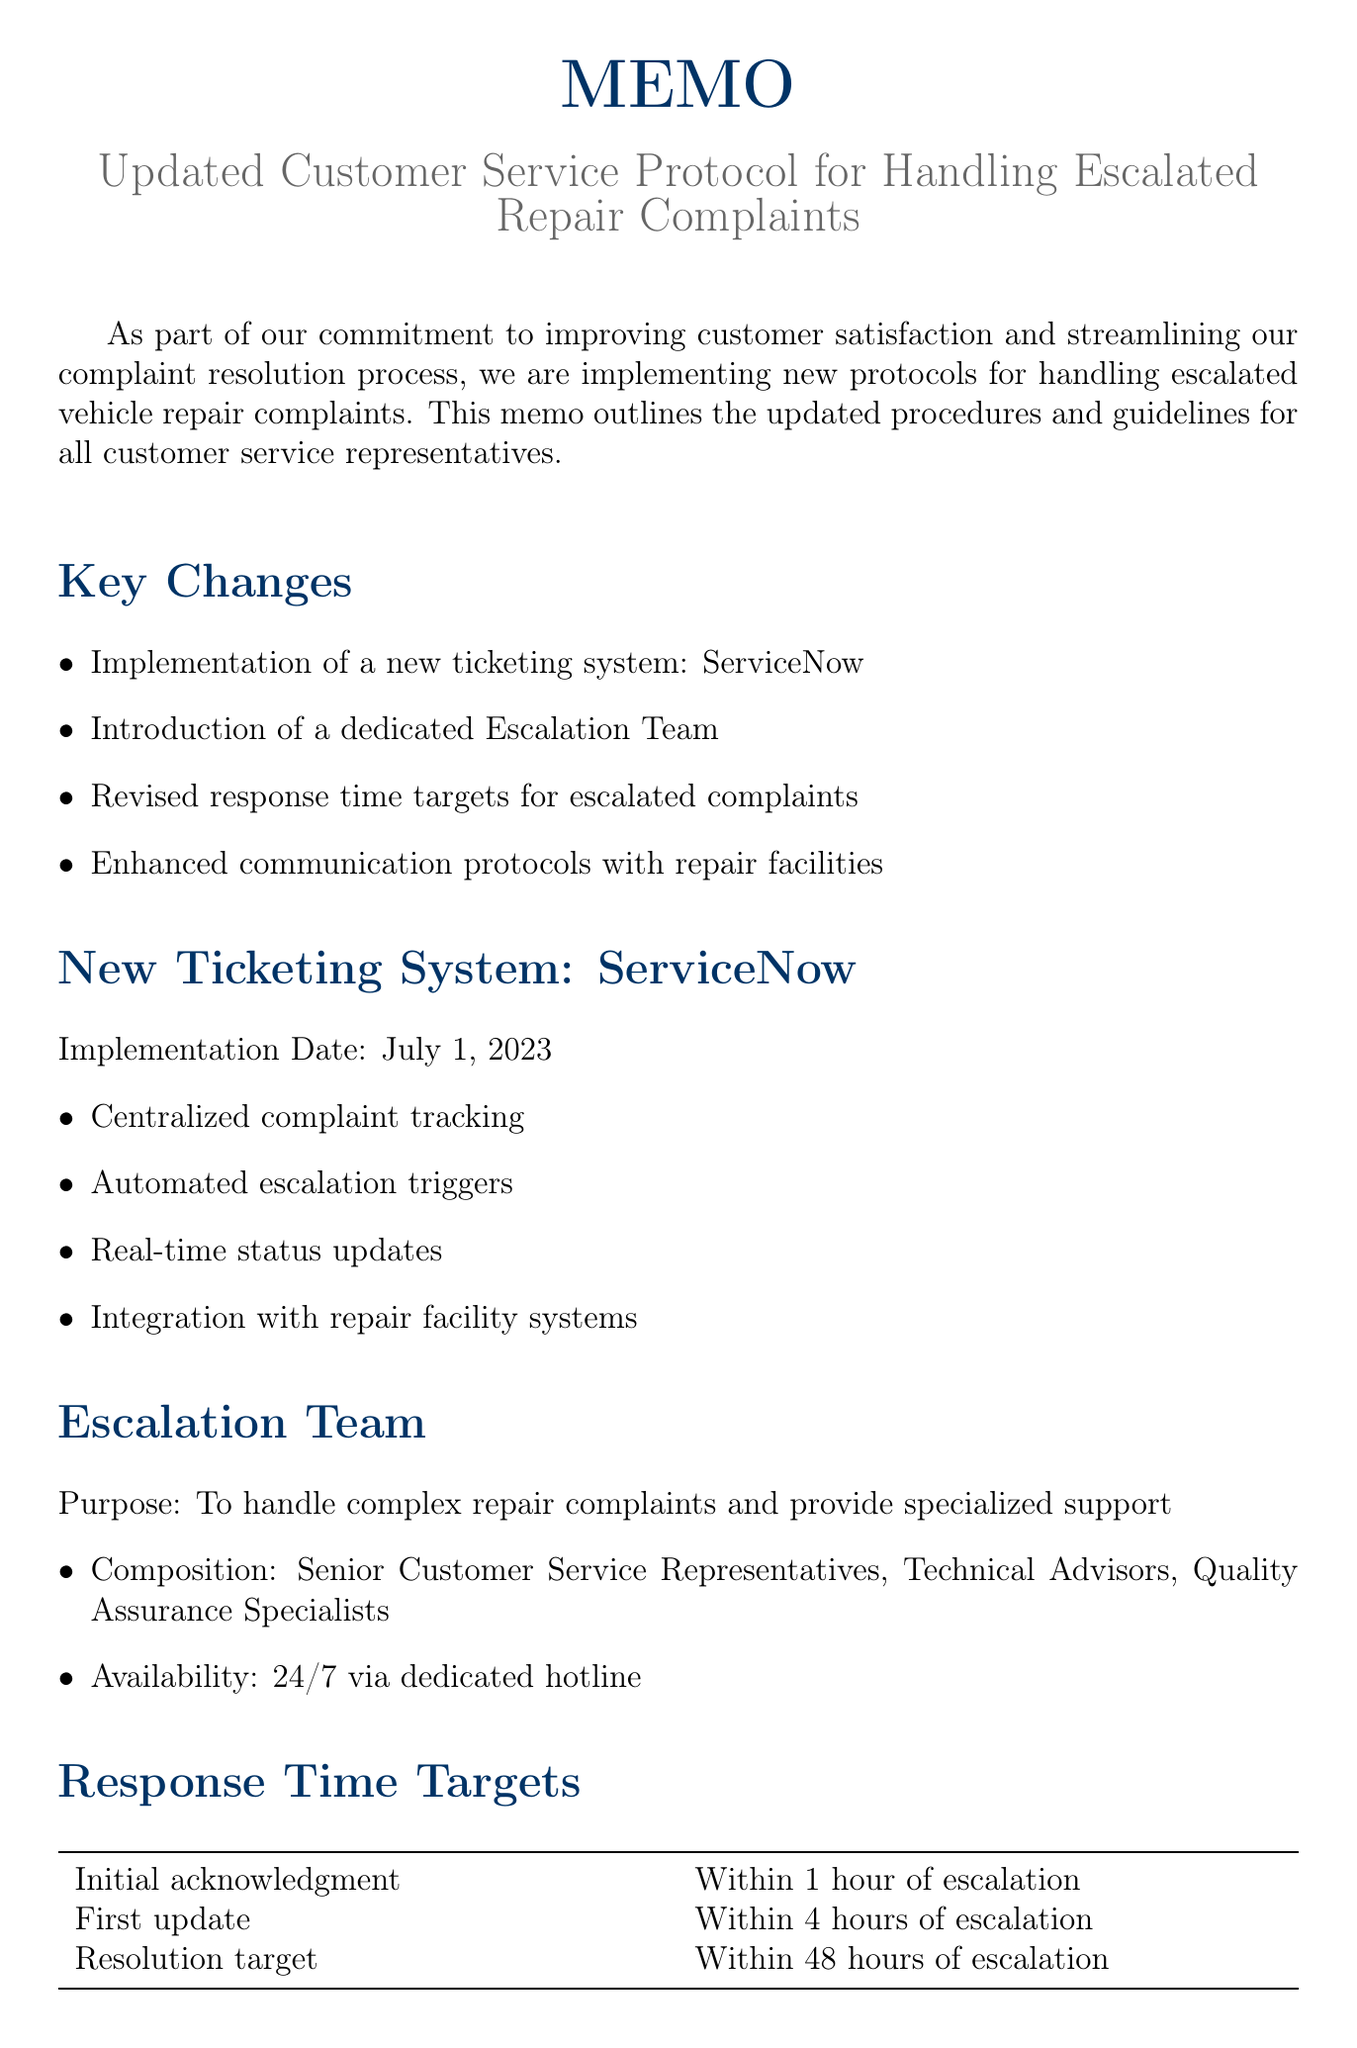What is the title of the memo? The title is explicitly stated at the top of the document, indicating the focus of the memo.
Answer: Updated Customer Service Protocol for Handling Escalated Repair Complaints What is the name of the new ticketing system? The document mentions the specific ticketing system that is being implemented for handling complaints.
Answer: ServiceNow Who is the lead of the Escalation Team? The key contacts section provides names of individuals in leadership roles, including the Escalation Team lead.
Answer: Sarah Johnson What is the implementation date of the new ticketing system? There is a specific date mentioned for when the new ticketing system will be put into use.
Answer: July 1, 2023 What is the initial acknowledgment response time target? The memo outlines specific targets for response times to escalations, which are listed in a table.
Answer: Within 1 hour of escalation What are the composition roles of the Escalation Team? The memo details the types of professionals that make up the Escalation Team, highlighting their expertise.
Answer: Senior Customer Service Representatives, Technical Advisors, Quality Assurance Specialists What criteria warrant an escalation? The document lists specific conditions that necessitate escalation in the complaint process.
Answer: Repairs exceeding 5 business days, Multiple failed repair attempts, Customer dissatisfaction with initial resolution, Safety-related concerns What is included in the resources for training? The document specifies necessary resources that will aid in enhancing the skills of customer service representatives.
Answer: Updated Repair Complaint Handbook, Access to TechLine for real-time manufacturer support, Subscription to AllData for comprehensive vehicle repair information 